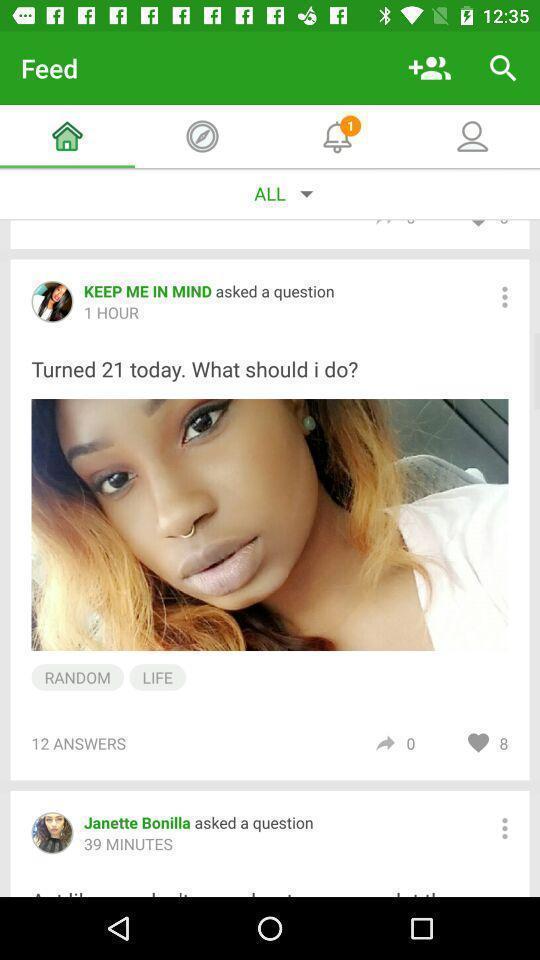Summarize the main components in this picture. Various feed displayed of a social media app. 